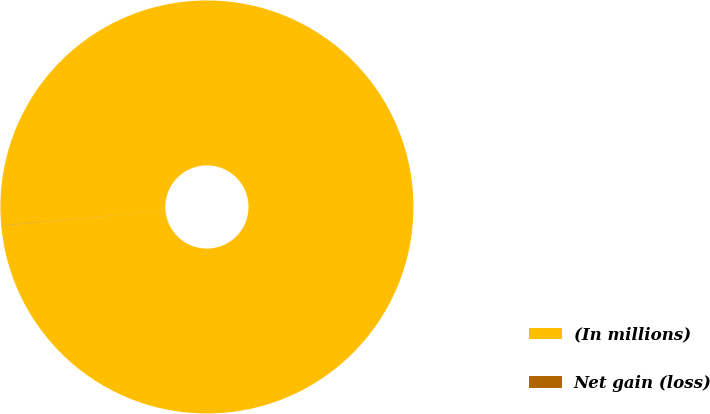Convert chart. <chart><loc_0><loc_0><loc_500><loc_500><pie_chart><fcel>(In millions)<fcel>Net gain (loss)<nl><fcel>99.98%<fcel>0.02%<nl></chart> 